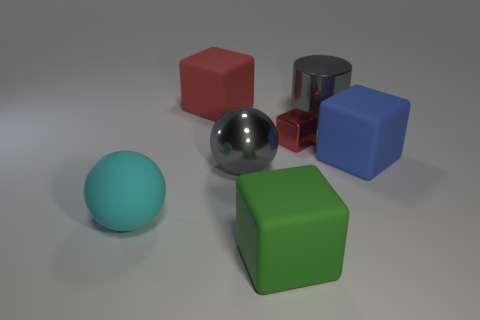Is there any other thing that has the same size as the metal block?
Offer a very short reply. No. How many objects are either large gray metal cylinders or large green blocks?
Offer a very short reply. 2. Is there a green thing that has the same shape as the big blue object?
Your answer should be compact. Yes. There is a shiny object left of the green rubber block; is it the same color as the cylinder?
Provide a succinct answer. Yes. What shape is the matte object right of the large metallic object behind the big gray ball?
Provide a short and direct response. Cube. Is there a cyan metal ball that has the same size as the blue cube?
Offer a terse response. No. Is the number of green objects less than the number of small blue blocks?
Offer a terse response. No. What is the shape of the large gray shiny object to the right of the large matte object that is in front of the thing to the left of the red matte object?
Ensure brevity in your answer.  Cylinder. What number of things are large gray shiny things that are left of the red metal thing or big rubber blocks on the left side of the small red metallic object?
Offer a very short reply. 3. There is a big cyan matte thing; are there any blue matte things in front of it?
Your response must be concise. No. 